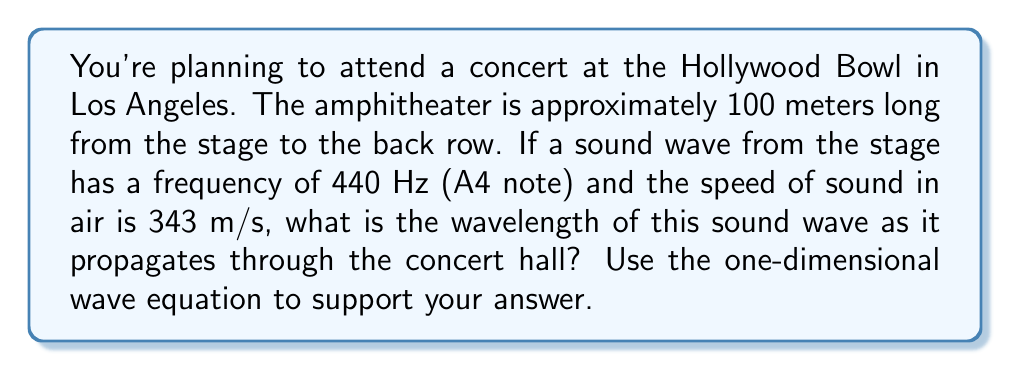Can you solve this math problem? To solve this problem, we'll use the one-dimensional wave equation and the relationship between wave speed, frequency, and wavelength.

1. The one-dimensional wave equation is given by:

   $$\frac{\partial^2 u}{\partial t^2} = c^2 \frac{\partial^2 u}{\partial x^2}$$

   where $u$ is the displacement, $t$ is time, $x$ is position, and $c$ is the wave speed.

2. For a harmonic wave, the general solution to this equation is:

   $$u(x,t) = A \sin(kx - \omega t)$$

   where $A$ is the amplitude, $k$ is the wave number, and $\omega$ is the angular frequency.

3. The wave number $k$ is related to the wavelength $\lambda$ by:

   $$k = \frac{2\pi}{\lambda}$$

4. The angular frequency $\omega$ is related to the frequency $f$ by:

   $$\omega = 2\pi f$$

5. The wave speed $c$ is related to $k$ and $\omega$ by:

   $$c = \frac{\omega}{k}$$

6. We also know that wave speed is related to frequency and wavelength by:

   $$c = f\lambda$$

7. Given:
   - Frequency $f = 440$ Hz
   - Speed of sound $c = 343$ m/s

8. Using the equation from step 6, we can solve for the wavelength:

   $$\lambda = \frac{c}{f} = \frac{343 \text{ m/s}}{440 \text{ Hz}} = 0.78 \text{ m}$$

Thus, the wavelength of the 440 Hz sound wave in the concert hall is approximately 0.78 meters.
Answer: 0.78 m 